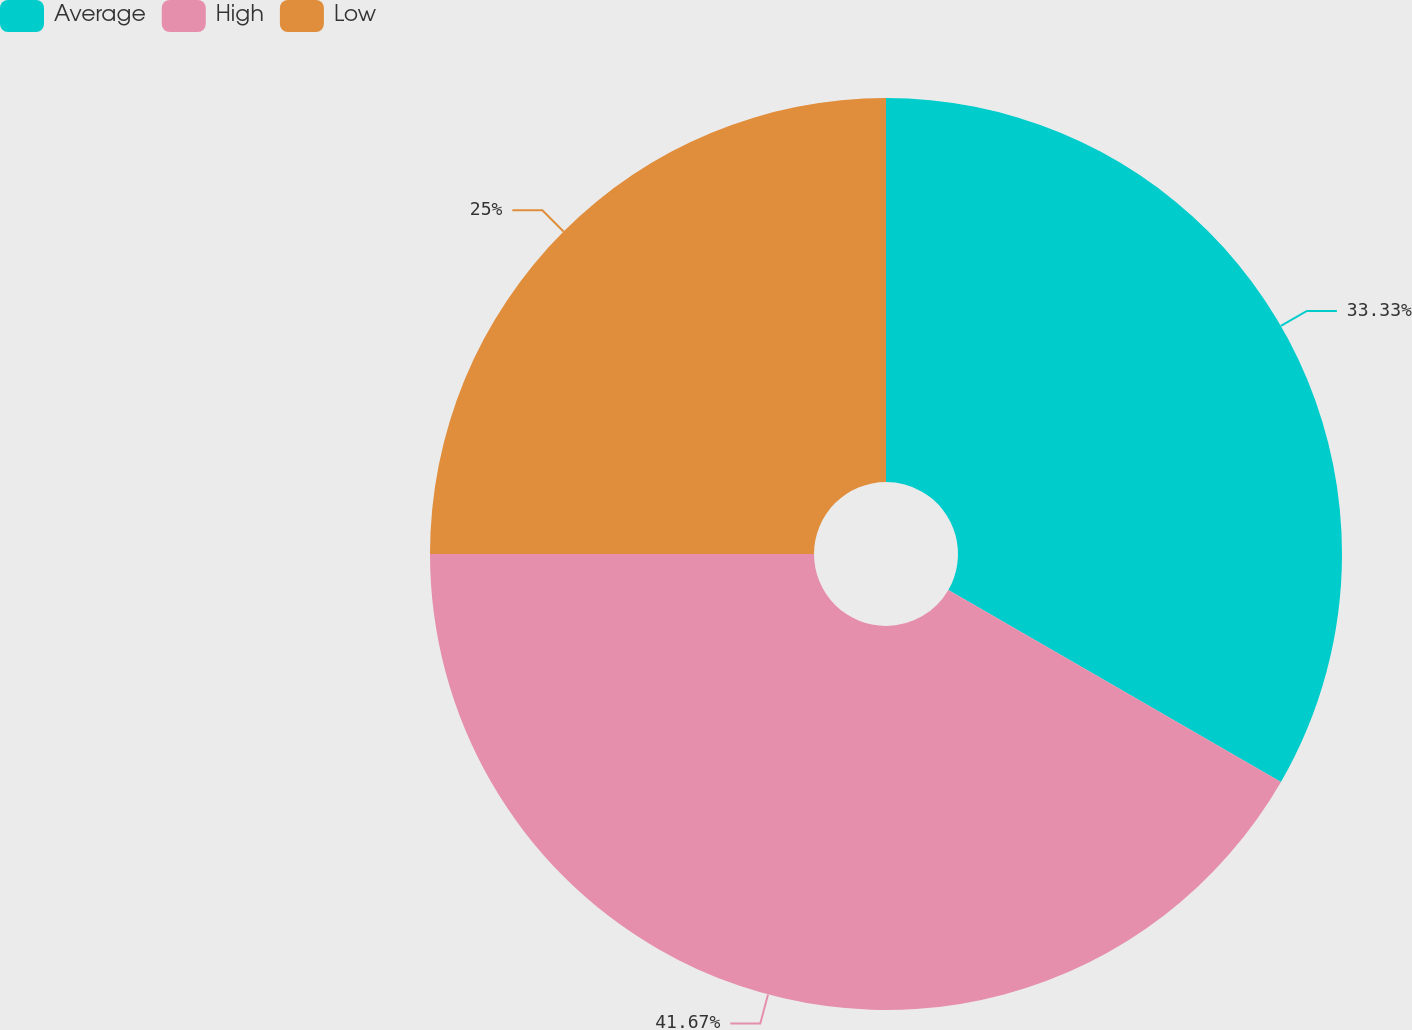Convert chart to OTSL. <chart><loc_0><loc_0><loc_500><loc_500><pie_chart><fcel>Average<fcel>High<fcel>Low<nl><fcel>33.33%<fcel>41.67%<fcel>25.0%<nl></chart> 